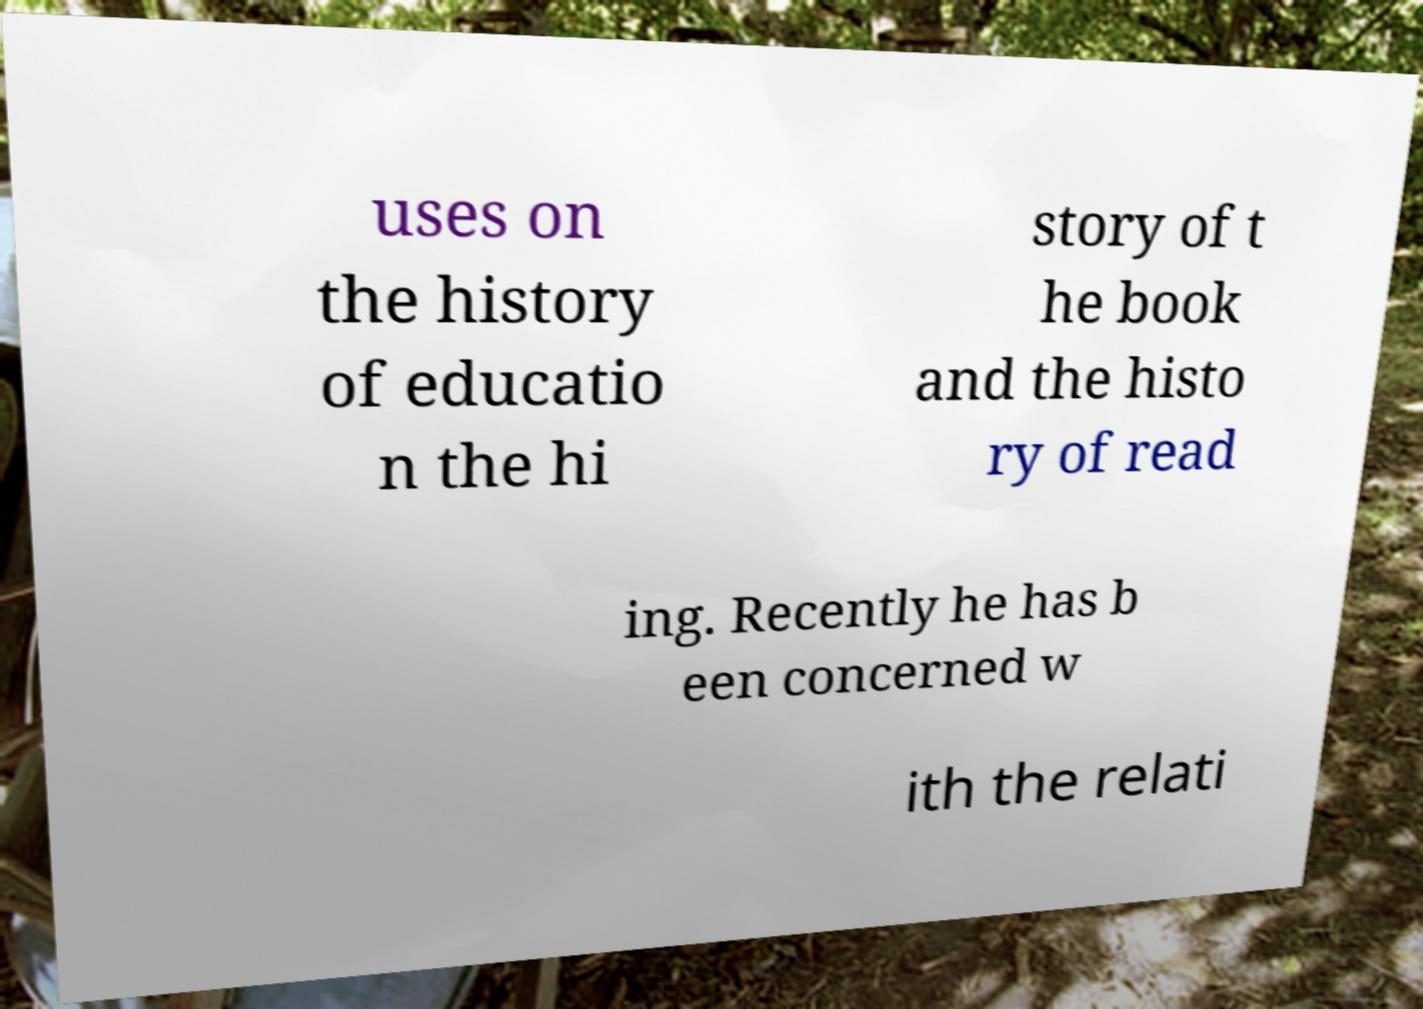I need the written content from this picture converted into text. Can you do that? uses on the history of educatio n the hi story of t he book and the histo ry of read ing. Recently he has b een concerned w ith the relati 